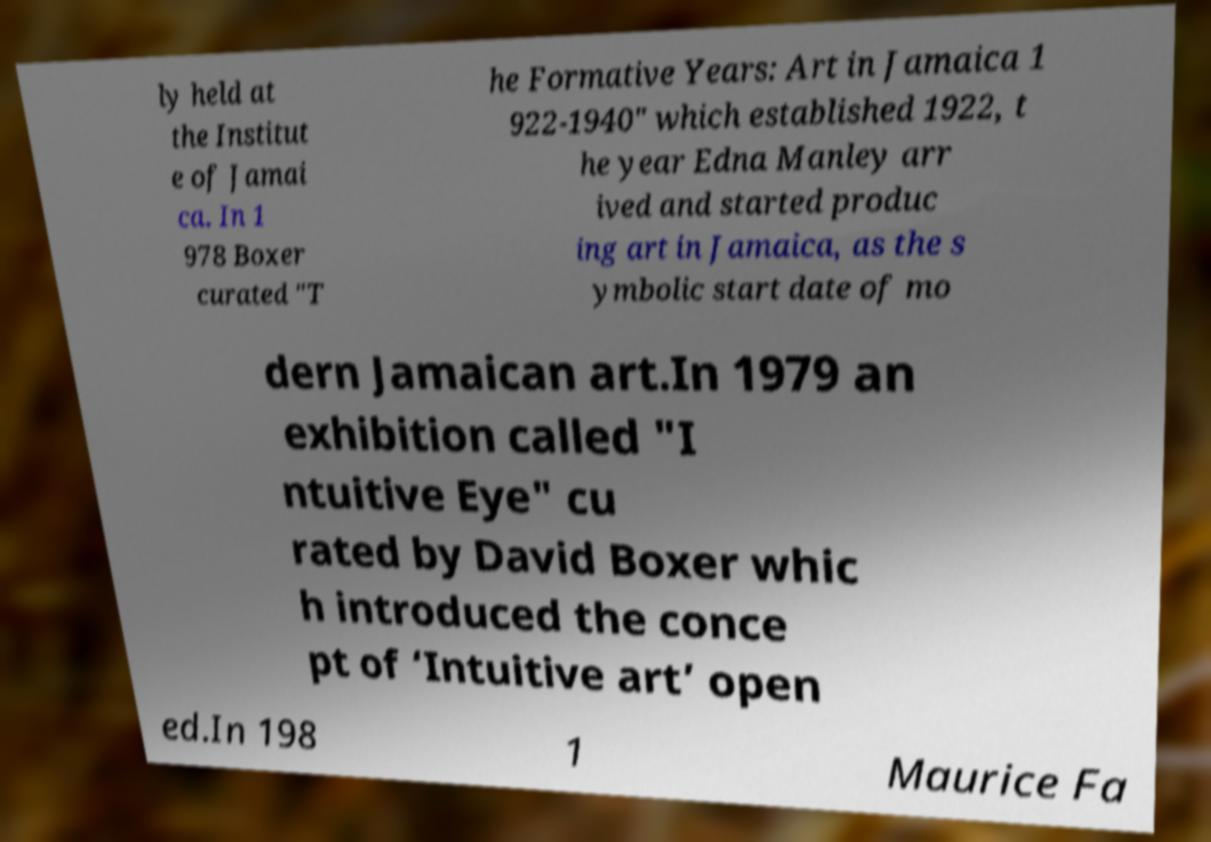Could you assist in decoding the text presented in this image and type it out clearly? ly held at the Institut e of Jamai ca. In 1 978 Boxer curated "T he Formative Years: Art in Jamaica 1 922-1940" which established 1922, t he year Edna Manley arr ived and started produc ing art in Jamaica, as the s ymbolic start date of mo dern Jamaican art.In 1979 an exhibition called "I ntuitive Eye" cu rated by David Boxer whic h introduced the conce pt of ‘Intuitive art’ open ed.In 198 1 Maurice Fa 